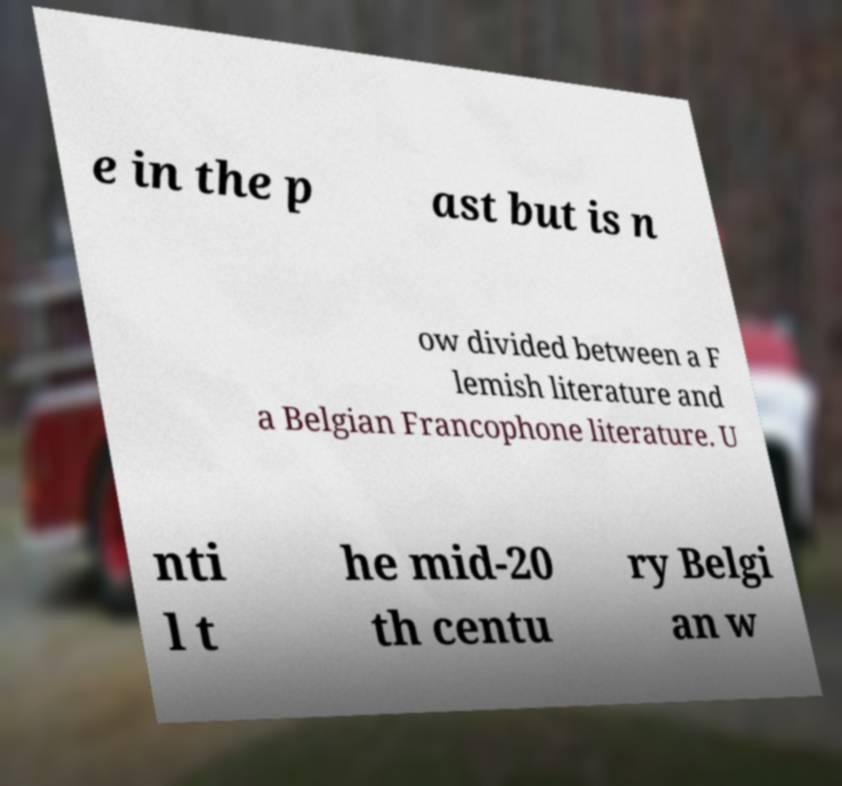Please identify and transcribe the text found in this image. e in the p ast but is n ow divided between a F lemish literature and a Belgian Francophone literature. U nti l t he mid-20 th centu ry Belgi an w 